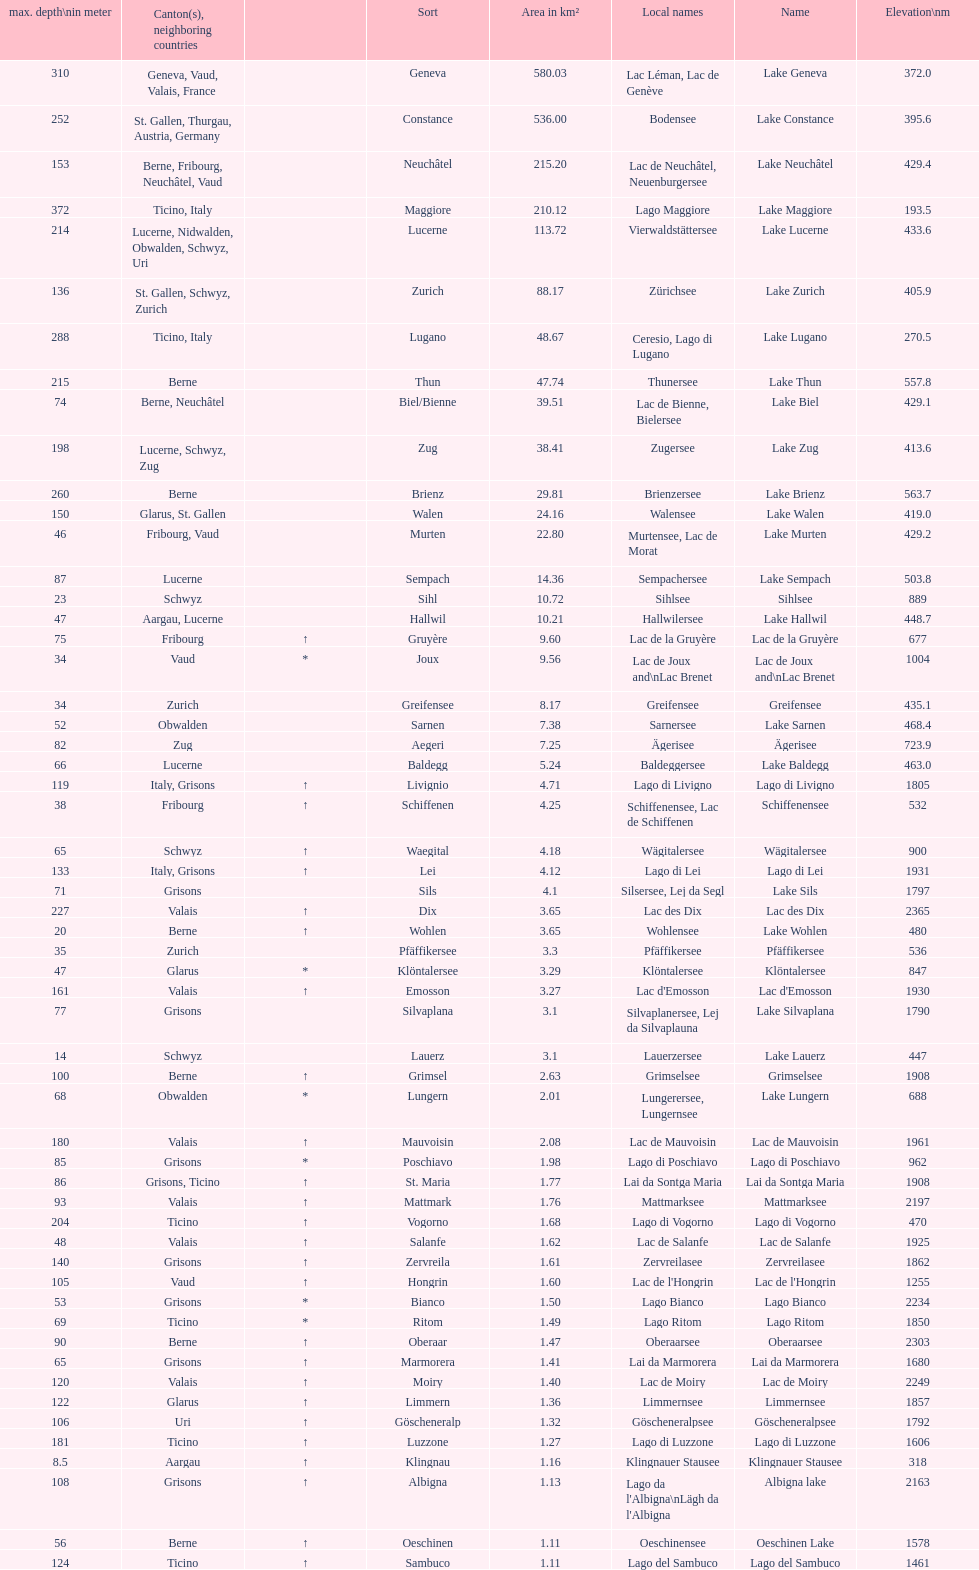What is the number of lakes that have an area less than 100 km squared? 51. 